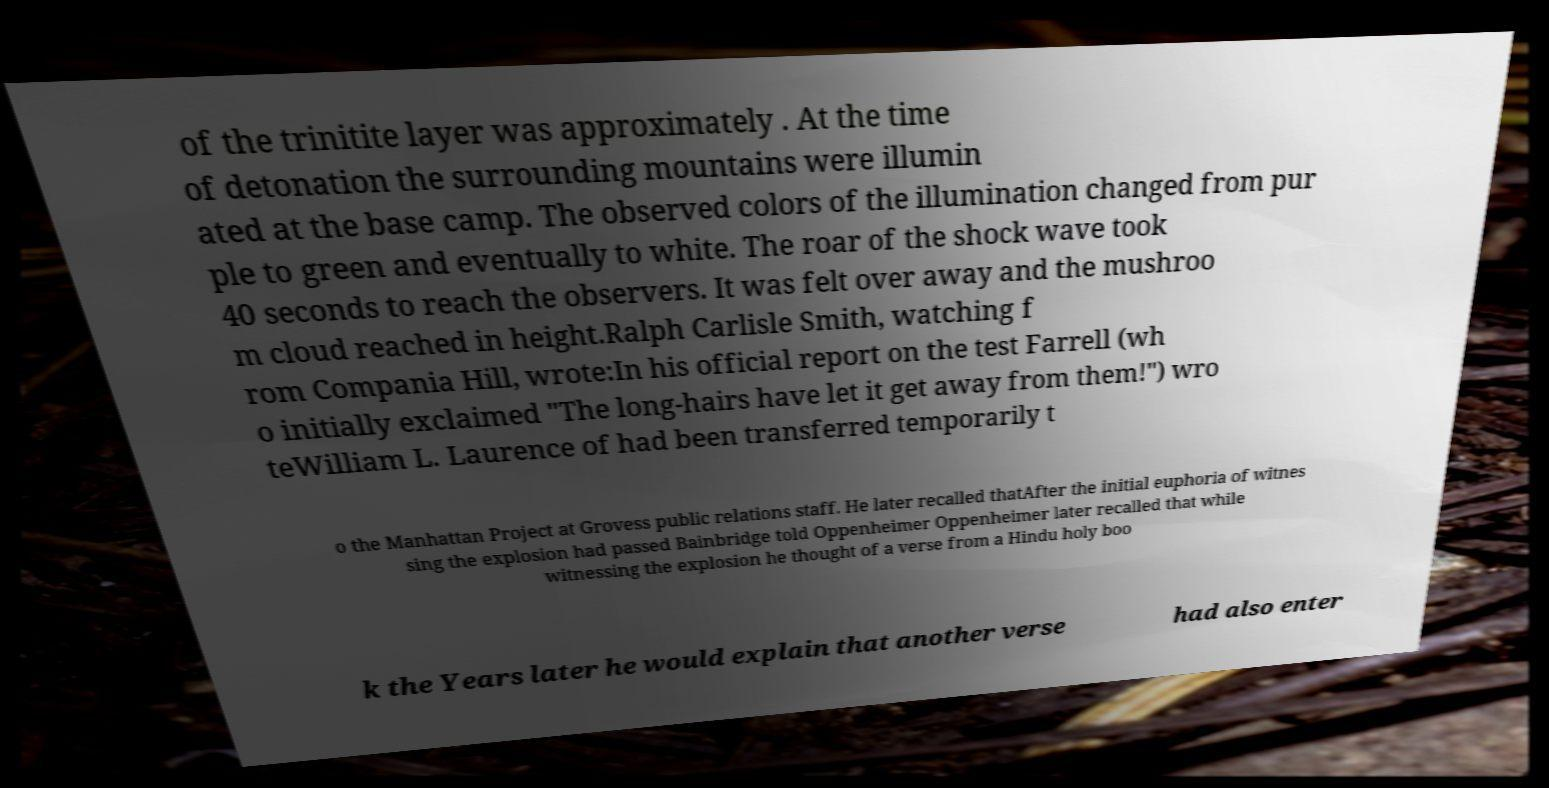Please read and relay the text visible in this image. What does it say? of the trinitite layer was approximately . At the time of detonation the surrounding mountains were illumin ated at the base camp. The observed colors of the illumination changed from pur ple to green and eventually to white. The roar of the shock wave took 40 seconds to reach the observers. It was felt over away and the mushroo m cloud reached in height.Ralph Carlisle Smith, watching f rom Compania Hill, wrote:In his official report on the test Farrell (wh o initially exclaimed "The long-hairs have let it get away from them!") wro teWilliam L. Laurence of had been transferred temporarily t o the Manhattan Project at Grovess public relations staff. He later recalled thatAfter the initial euphoria of witnes sing the explosion had passed Bainbridge told Oppenheimer Oppenheimer later recalled that while witnessing the explosion he thought of a verse from a Hindu holy boo k the Years later he would explain that another verse had also enter 